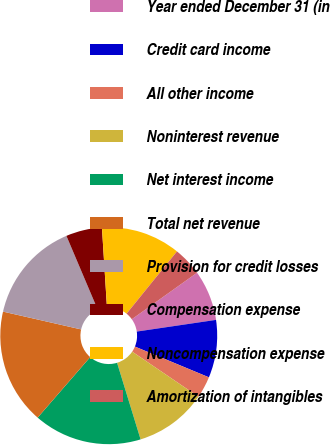Convert chart to OTSL. <chart><loc_0><loc_0><loc_500><loc_500><pie_chart><fcel>Year ended December 31 (in<fcel>Credit card income<fcel>All other income<fcel>Noninterest revenue<fcel>Net interest income<fcel>Total net revenue<fcel>Provision for credit losses<fcel>Compensation expense<fcel>Noncompensation expense<fcel>Amortization of intangibles<nl><fcel>7.53%<fcel>8.6%<fcel>3.24%<fcel>10.75%<fcel>16.12%<fcel>17.19%<fcel>15.05%<fcel>5.38%<fcel>11.83%<fcel>4.31%<nl></chart> 